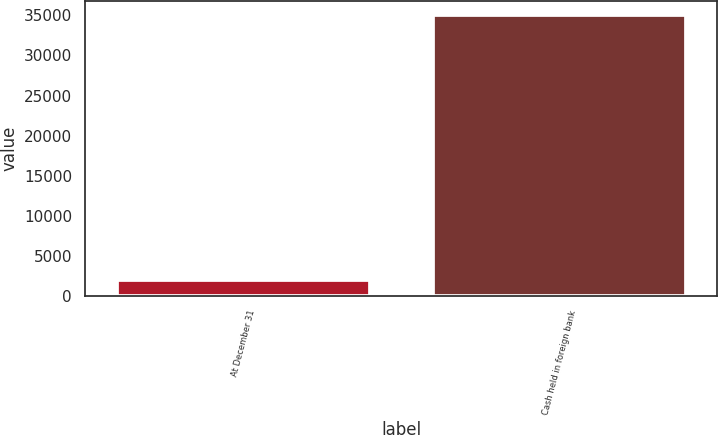<chart> <loc_0><loc_0><loc_500><loc_500><bar_chart><fcel>At December 31<fcel>Cash held in foreign bank<nl><fcel>2014<fcel>35065<nl></chart> 